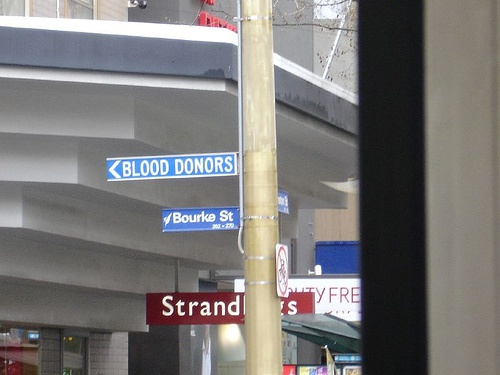Describe the objects in this image and their specific colors. I can see various objects in this image with different colors. 